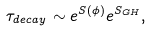<formula> <loc_0><loc_0><loc_500><loc_500>\tau _ { d e c a y } \sim e ^ { S ( \phi ) } e ^ { S _ { G H } } ,</formula> 